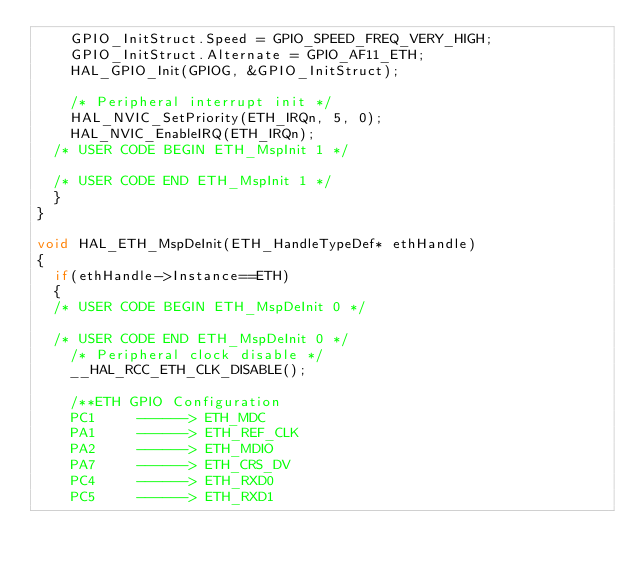Convert code to text. <code><loc_0><loc_0><loc_500><loc_500><_C_>    GPIO_InitStruct.Speed = GPIO_SPEED_FREQ_VERY_HIGH;
    GPIO_InitStruct.Alternate = GPIO_AF11_ETH;
    HAL_GPIO_Init(GPIOG, &GPIO_InitStruct);

    /* Peripheral interrupt init */
    HAL_NVIC_SetPriority(ETH_IRQn, 5, 0);
    HAL_NVIC_EnableIRQ(ETH_IRQn);
  /* USER CODE BEGIN ETH_MspInit 1 */

  /* USER CODE END ETH_MspInit 1 */
  }
}

void HAL_ETH_MspDeInit(ETH_HandleTypeDef* ethHandle)
{
  if(ethHandle->Instance==ETH)
  {
  /* USER CODE BEGIN ETH_MspDeInit 0 */

  /* USER CODE END ETH_MspDeInit 0 */
    /* Peripheral clock disable */
    __HAL_RCC_ETH_CLK_DISABLE();
  
    /**ETH GPIO Configuration    
    PC1     ------> ETH_MDC
    PA1     ------> ETH_REF_CLK
    PA2     ------> ETH_MDIO
    PA7     ------> ETH_CRS_DV
    PC4     ------> ETH_RXD0
    PC5     ------> ETH_RXD1</code> 